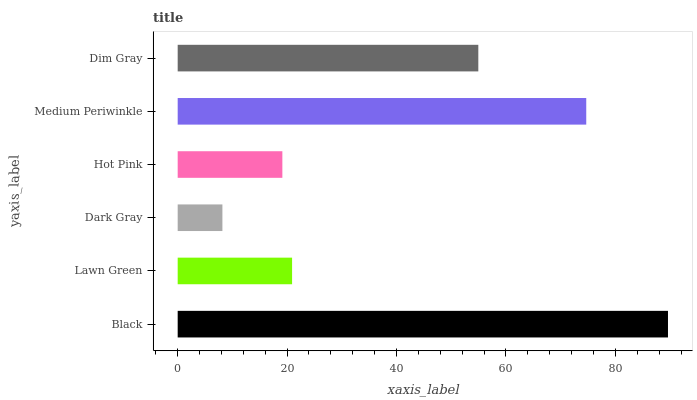Is Dark Gray the minimum?
Answer yes or no. Yes. Is Black the maximum?
Answer yes or no. Yes. Is Lawn Green the minimum?
Answer yes or no. No. Is Lawn Green the maximum?
Answer yes or no. No. Is Black greater than Lawn Green?
Answer yes or no. Yes. Is Lawn Green less than Black?
Answer yes or no. Yes. Is Lawn Green greater than Black?
Answer yes or no. No. Is Black less than Lawn Green?
Answer yes or no. No. Is Dim Gray the high median?
Answer yes or no. Yes. Is Lawn Green the low median?
Answer yes or no. Yes. Is Lawn Green the high median?
Answer yes or no. No. Is Dim Gray the low median?
Answer yes or no. No. 